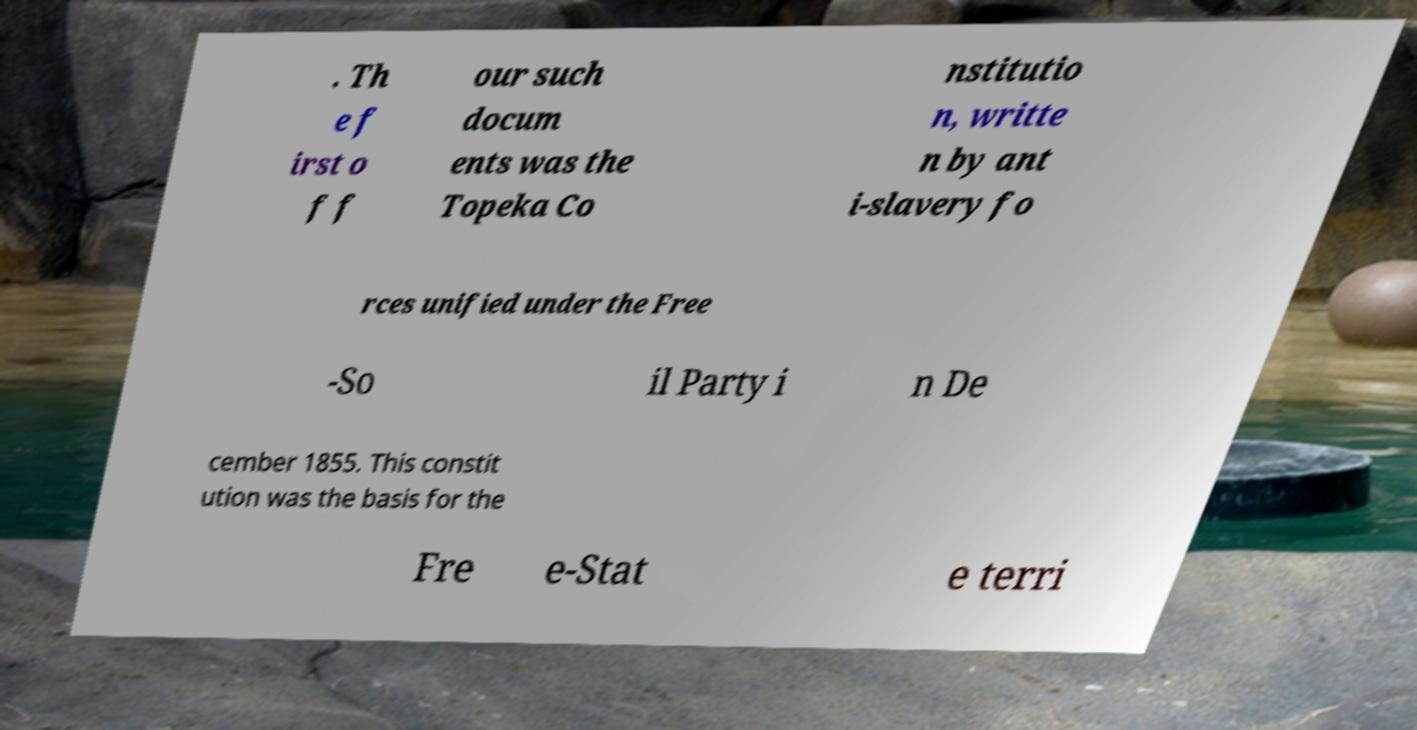For documentation purposes, I need the text within this image transcribed. Could you provide that? . Th e f irst o f f our such docum ents was the Topeka Co nstitutio n, writte n by ant i-slavery fo rces unified under the Free -So il Party i n De cember 1855. This constit ution was the basis for the Fre e-Stat e terri 